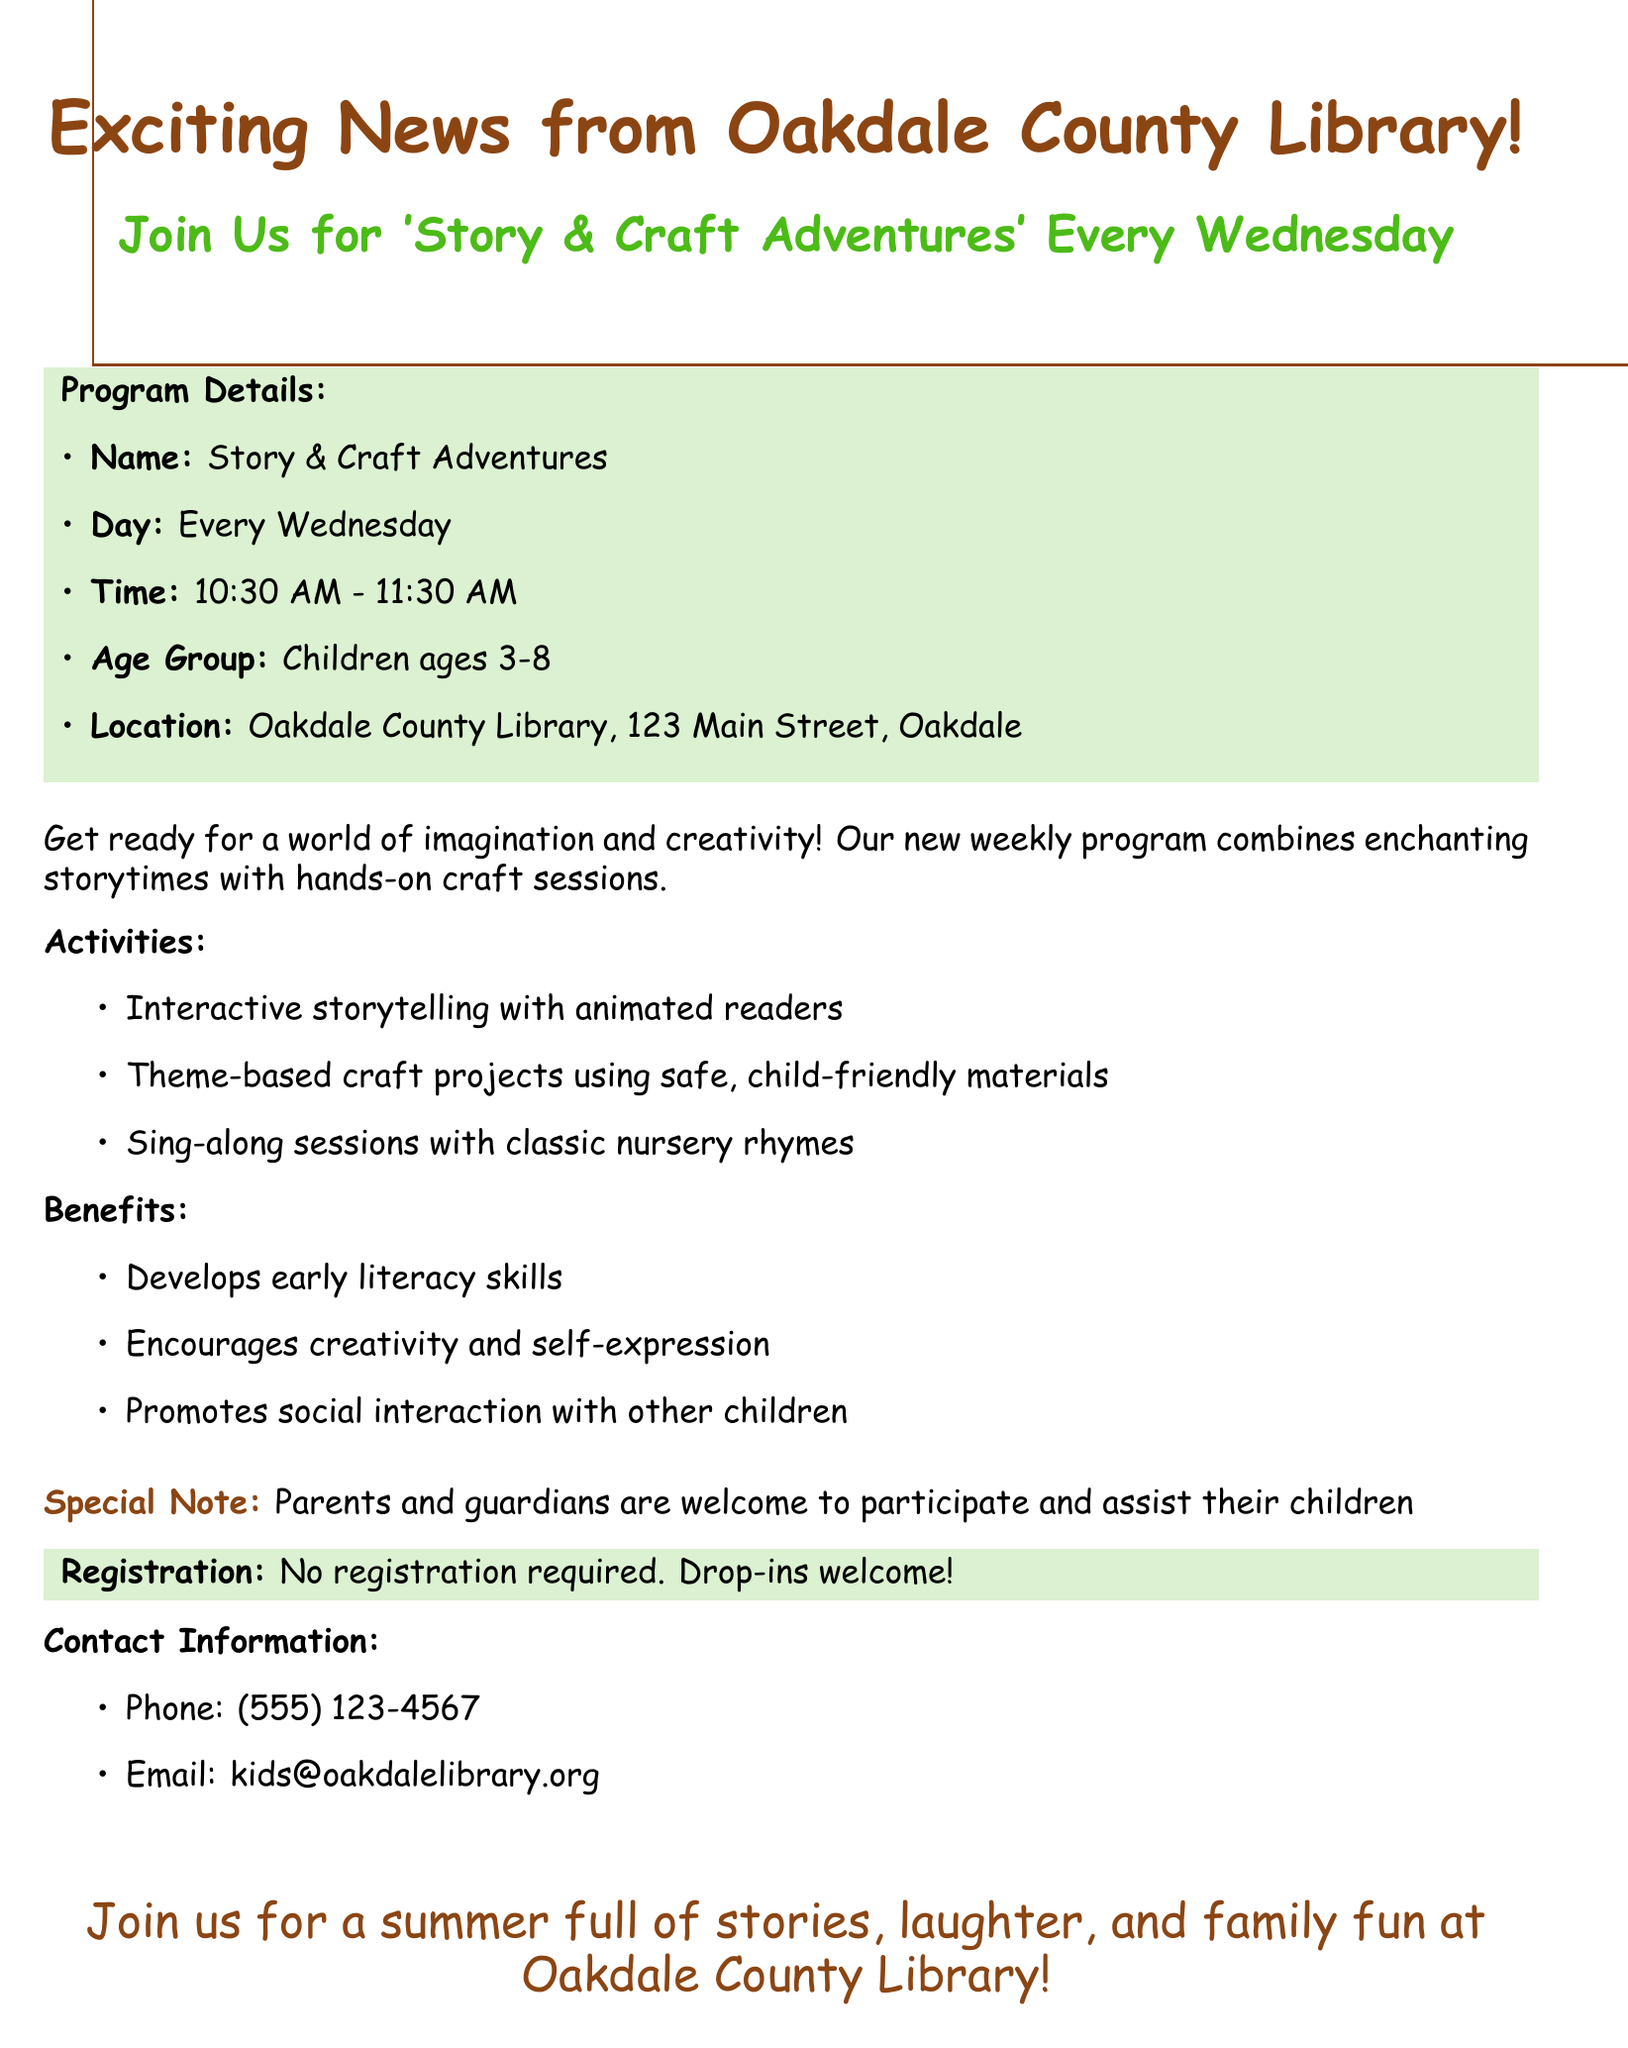What is the name of the program? The name of the program is mentioned at the beginning of the document, which is "Story & Craft Adventures."
Answer: Story & Craft Adventures What day does the program take place? The document specifies that the program occurs "Every Wednesday."
Answer: Every Wednesday What time does the program start? The starting time for the program is listed in the document as "10:30 AM."
Answer: 10:30 AM What age group is the program intended for? The document indicates that the program is for "Children ages 3-8."
Answer: Children ages 3-8 Is registration required for the program? The document states under the registration section that "No registration required."
Answer: No registration required What is one activity mentioned in the document? The activities listed include multiple options, one being "Interactive storytelling."
Answer: Interactive storytelling What is a benefit of the program? One of the benefits mentioned in the document is that the program "Develops early literacy skills."
Answer: Develops early literacy skills Where is the location of the program? The document provides the address of the location as "Oakdale County Library, 123 Main Street, Oakdale."
Answer: Oakdale County Library, 123 Main Street, Oakdale What contact method is provided in the document? The document lists contact options, and one method is "Phone."
Answer: Phone 